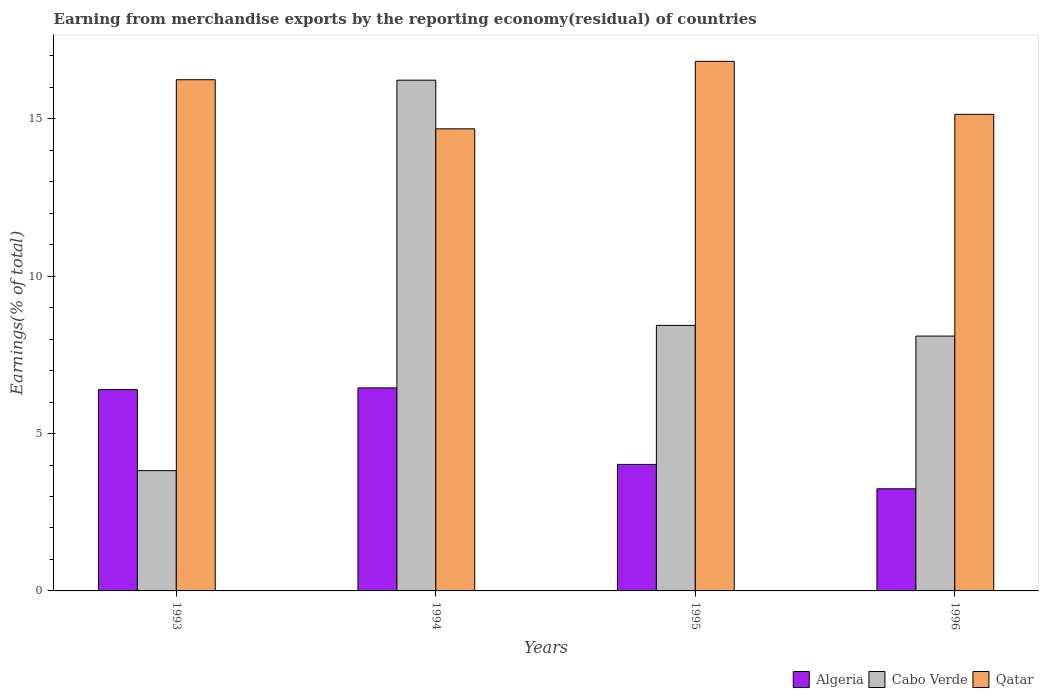How many different coloured bars are there?
Your response must be concise. 3. How many bars are there on the 3rd tick from the left?
Your response must be concise. 3. What is the label of the 4th group of bars from the left?
Provide a succinct answer. 1996. What is the percentage of amount earned from merchandise exports in Algeria in 1994?
Offer a terse response. 6.45. Across all years, what is the maximum percentage of amount earned from merchandise exports in Algeria?
Your answer should be very brief. 6.45. Across all years, what is the minimum percentage of amount earned from merchandise exports in Qatar?
Your answer should be compact. 14.68. What is the total percentage of amount earned from merchandise exports in Qatar in the graph?
Ensure brevity in your answer.  62.88. What is the difference between the percentage of amount earned from merchandise exports in Qatar in 1994 and that in 1996?
Give a very brief answer. -0.46. What is the difference between the percentage of amount earned from merchandise exports in Algeria in 1996 and the percentage of amount earned from merchandise exports in Qatar in 1994?
Your answer should be very brief. -11.44. What is the average percentage of amount earned from merchandise exports in Qatar per year?
Ensure brevity in your answer.  15.72. In the year 1995, what is the difference between the percentage of amount earned from merchandise exports in Qatar and percentage of amount earned from merchandise exports in Algeria?
Offer a very short reply. 12.8. In how many years, is the percentage of amount earned from merchandise exports in Cabo Verde greater than 8 %?
Provide a succinct answer. 3. What is the ratio of the percentage of amount earned from merchandise exports in Qatar in 1993 to that in 1996?
Provide a short and direct response. 1.07. What is the difference between the highest and the second highest percentage of amount earned from merchandise exports in Algeria?
Your answer should be compact. 0.05. What is the difference between the highest and the lowest percentage of amount earned from merchandise exports in Cabo Verde?
Your answer should be compact. 12.4. In how many years, is the percentage of amount earned from merchandise exports in Cabo Verde greater than the average percentage of amount earned from merchandise exports in Cabo Verde taken over all years?
Your answer should be compact. 1. Is the sum of the percentage of amount earned from merchandise exports in Cabo Verde in 1993 and 1995 greater than the maximum percentage of amount earned from merchandise exports in Algeria across all years?
Your response must be concise. Yes. What does the 1st bar from the left in 1996 represents?
Your answer should be very brief. Algeria. What does the 2nd bar from the right in 1993 represents?
Offer a terse response. Cabo Verde. Are all the bars in the graph horizontal?
Provide a succinct answer. No. Does the graph contain grids?
Provide a short and direct response. No. Where does the legend appear in the graph?
Keep it short and to the point. Bottom right. How many legend labels are there?
Give a very brief answer. 3. What is the title of the graph?
Your answer should be compact. Earning from merchandise exports by the reporting economy(residual) of countries. What is the label or title of the X-axis?
Your answer should be very brief. Years. What is the label or title of the Y-axis?
Provide a succinct answer. Earnings(% of total). What is the Earnings(% of total) in Algeria in 1993?
Your answer should be very brief. 6.4. What is the Earnings(% of total) in Cabo Verde in 1993?
Give a very brief answer. 3.82. What is the Earnings(% of total) of Qatar in 1993?
Offer a terse response. 16.24. What is the Earnings(% of total) in Algeria in 1994?
Keep it short and to the point. 6.45. What is the Earnings(% of total) in Cabo Verde in 1994?
Your response must be concise. 16.23. What is the Earnings(% of total) of Qatar in 1994?
Give a very brief answer. 14.68. What is the Earnings(% of total) in Algeria in 1995?
Make the answer very short. 4.02. What is the Earnings(% of total) in Cabo Verde in 1995?
Ensure brevity in your answer.  8.44. What is the Earnings(% of total) in Qatar in 1995?
Offer a terse response. 16.82. What is the Earnings(% of total) in Algeria in 1996?
Offer a terse response. 3.24. What is the Earnings(% of total) of Cabo Verde in 1996?
Give a very brief answer. 8.1. What is the Earnings(% of total) in Qatar in 1996?
Provide a succinct answer. 15.14. Across all years, what is the maximum Earnings(% of total) of Algeria?
Ensure brevity in your answer.  6.45. Across all years, what is the maximum Earnings(% of total) in Cabo Verde?
Ensure brevity in your answer.  16.23. Across all years, what is the maximum Earnings(% of total) of Qatar?
Offer a very short reply. 16.82. Across all years, what is the minimum Earnings(% of total) of Algeria?
Provide a short and direct response. 3.24. Across all years, what is the minimum Earnings(% of total) in Cabo Verde?
Your answer should be compact. 3.82. Across all years, what is the minimum Earnings(% of total) in Qatar?
Ensure brevity in your answer.  14.68. What is the total Earnings(% of total) of Algeria in the graph?
Your answer should be very brief. 20.11. What is the total Earnings(% of total) of Cabo Verde in the graph?
Keep it short and to the point. 36.58. What is the total Earnings(% of total) of Qatar in the graph?
Your answer should be compact. 62.88. What is the difference between the Earnings(% of total) in Algeria in 1993 and that in 1994?
Your response must be concise. -0.05. What is the difference between the Earnings(% of total) in Cabo Verde in 1993 and that in 1994?
Provide a short and direct response. -12.4. What is the difference between the Earnings(% of total) of Qatar in 1993 and that in 1994?
Give a very brief answer. 1.56. What is the difference between the Earnings(% of total) in Algeria in 1993 and that in 1995?
Make the answer very short. 2.38. What is the difference between the Earnings(% of total) of Cabo Verde in 1993 and that in 1995?
Keep it short and to the point. -4.61. What is the difference between the Earnings(% of total) in Qatar in 1993 and that in 1995?
Provide a succinct answer. -0.58. What is the difference between the Earnings(% of total) in Algeria in 1993 and that in 1996?
Your response must be concise. 3.15. What is the difference between the Earnings(% of total) of Cabo Verde in 1993 and that in 1996?
Provide a succinct answer. -4.27. What is the difference between the Earnings(% of total) in Qatar in 1993 and that in 1996?
Your answer should be compact. 1.1. What is the difference between the Earnings(% of total) of Algeria in 1994 and that in 1995?
Offer a very short reply. 2.43. What is the difference between the Earnings(% of total) of Cabo Verde in 1994 and that in 1995?
Keep it short and to the point. 7.79. What is the difference between the Earnings(% of total) of Qatar in 1994 and that in 1995?
Make the answer very short. -2.14. What is the difference between the Earnings(% of total) in Algeria in 1994 and that in 1996?
Provide a short and direct response. 3.21. What is the difference between the Earnings(% of total) of Cabo Verde in 1994 and that in 1996?
Provide a short and direct response. 8.13. What is the difference between the Earnings(% of total) in Qatar in 1994 and that in 1996?
Provide a short and direct response. -0.46. What is the difference between the Earnings(% of total) in Algeria in 1995 and that in 1996?
Offer a very short reply. 0.77. What is the difference between the Earnings(% of total) in Cabo Verde in 1995 and that in 1996?
Provide a succinct answer. 0.34. What is the difference between the Earnings(% of total) of Qatar in 1995 and that in 1996?
Your answer should be compact. 1.68. What is the difference between the Earnings(% of total) in Algeria in 1993 and the Earnings(% of total) in Cabo Verde in 1994?
Make the answer very short. -9.83. What is the difference between the Earnings(% of total) in Algeria in 1993 and the Earnings(% of total) in Qatar in 1994?
Your answer should be very brief. -8.28. What is the difference between the Earnings(% of total) in Cabo Verde in 1993 and the Earnings(% of total) in Qatar in 1994?
Your answer should be very brief. -10.86. What is the difference between the Earnings(% of total) in Algeria in 1993 and the Earnings(% of total) in Cabo Verde in 1995?
Provide a short and direct response. -2.04. What is the difference between the Earnings(% of total) in Algeria in 1993 and the Earnings(% of total) in Qatar in 1995?
Keep it short and to the point. -10.43. What is the difference between the Earnings(% of total) in Cabo Verde in 1993 and the Earnings(% of total) in Qatar in 1995?
Provide a succinct answer. -13. What is the difference between the Earnings(% of total) in Algeria in 1993 and the Earnings(% of total) in Cabo Verde in 1996?
Your answer should be very brief. -1.7. What is the difference between the Earnings(% of total) of Algeria in 1993 and the Earnings(% of total) of Qatar in 1996?
Make the answer very short. -8.74. What is the difference between the Earnings(% of total) in Cabo Verde in 1993 and the Earnings(% of total) in Qatar in 1996?
Provide a short and direct response. -11.32. What is the difference between the Earnings(% of total) of Algeria in 1994 and the Earnings(% of total) of Cabo Verde in 1995?
Offer a terse response. -1.99. What is the difference between the Earnings(% of total) in Algeria in 1994 and the Earnings(% of total) in Qatar in 1995?
Ensure brevity in your answer.  -10.37. What is the difference between the Earnings(% of total) in Cabo Verde in 1994 and the Earnings(% of total) in Qatar in 1995?
Offer a very short reply. -0.6. What is the difference between the Earnings(% of total) in Algeria in 1994 and the Earnings(% of total) in Cabo Verde in 1996?
Provide a short and direct response. -1.65. What is the difference between the Earnings(% of total) of Algeria in 1994 and the Earnings(% of total) of Qatar in 1996?
Provide a succinct answer. -8.69. What is the difference between the Earnings(% of total) of Cabo Verde in 1994 and the Earnings(% of total) of Qatar in 1996?
Offer a very short reply. 1.09. What is the difference between the Earnings(% of total) of Algeria in 1995 and the Earnings(% of total) of Cabo Verde in 1996?
Offer a very short reply. -4.08. What is the difference between the Earnings(% of total) of Algeria in 1995 and the Earnings(% of total) of Qatar in 1996?
Offer a terse response. -11.12. What is the difference between the Earnings(% of total) in Cabo Verde in 1995 and the Earnings(% of total) in Qatar in 1996?
Ensure brevity in your answer.  -6.7. What is the average Earnings(% of total) in Algeria per year?
Ensure brevity in your answer.  5.03. What is the average Earnings(% of total) of Cabo Verde per year?
Your answer should be compact. 9.14. What is the average Earnings(% of total) of Qatar per year?
Provide a short and direct response. 15.72. In the year 1993, what is the difference between the Earnings(% of total) in Algeria and Earnings(% of total) in Cabo Verde?
Give a very brief answer. 2.57. In the year 1993, what is the difference between the Earnings(% of total) of Algeria and Earnings(% of total) of Qatar?
Offer a very short reply. -9.85. In the year 1993, what is the difference between the Earnings(% of total) of Cabo Verde and Earnings(% of total) of Qatar?
Your answer should be compact. -12.42. In the year 1994, what is the difference between the Earnings(% of total) in Algeria and Earnings(% of total) in Cabo Verde?
Ensure brevity in your answer.  -9.78. In the year 1994, what is the difference between the Earnings(% of total) in Algeria and Earnings(% of total) in Qatar?
Your answer should be compact. -8.23. In the year 1994, what is the difference between the Earnings(% of total) of Cabo Verde and Earnings(% of total) of Qatar?
Give a very brief answer. 1.55. In the year 1995, what is the difference between the Earnings(% of total) in Algeria and Earnings(% of total) in Cabo Verde?
Your answer should be compact. -4.42. In the year 1995, what is the difference between the Earnings(% of total) of Algeria and Earnings(% of total) of Qatar?
Offer a very short reply. -12.8. In the year 1995, what is the difference between the Earnings(% of total) of Cabo Verde and Earnings(% of total) of Qatar?
Make the answer very short. -8.39. In the year 1996, what is the difference between the Earnings(% of total) of Algeria and Earnings(% of total) of Cabo Verde?
Your answer should be very brief. -4.85. In the year 1996, what is the difference between the Earnings(% of total) of Algeria and Earnings(% of total) of Qatar?
Your response must be concise. -11.9. In the year 1996, what is the difference between the Earnings(% of total) of Cabo Verde and Earnings(% of total) of Qatar?
Ensure brevity in your answer.  -7.04. What is the ratio of the Earnings(% of total) of Algeria in 1993 to that in 1994?
Ensure brevity in your answer.  0.99. What is the ratio of the Earnings(% of total) in Cabo Verde in 1993 to that in 1994?
Ensure brevity in your answer.  0.24. What is the ratio of the Earnings(% of total) in Qatar in 1993 to that in 1994?
Offer a terse response. 1.11. What is the ratio of the Earnings(% of total) in Algeria in 1993 to that in 1995?
Offer a very short reply. 1.59. What is the ratio of the Earnings(% of total) in Cabo Verde in 1993 to that in 1995?
Offer a very short reply. 0.45. What is the ratio of the Earnings(% of total) in Qatar in 1993 to that in 1995?
Ensure brevity in your answer.  0.97. What is the ratio of the Earnings(% of total) of Algeria in 1993 to that in 1996?
Provide a short and direct response. 1.97. What is the ratio of the Earnings(% of total) of Cabo Verde in 1993 to that in 1996?
Make the answer very short. 0.47. What is the ratio of the Earnings(% of total) in Qatar in 1993 to that in 1996?
Make the answer very short. 1.07. What is the ratio of the Earnings(% of total) of Algeria in 1994 to that in 1995?
Give a very brief answer. 1.6. What is the ratio of the Earnings(% of total) in Cabo Verde in 1994 to that in 1995?
Your answer should be compact. 1.92. What is the ratio of the Earnings(% of total) in Qatar in 1994 to that in 1995?
Make the answer very short. 0.87. What is the ratio of the Earnings(% of total) in Algeria in 1994 to that in 1996?
Ensure brevity in your answer.  1.99. What is the ratio of the Earnings(% of total) in Cabo Verde in 1994 to that in 1996?
Keep it short and to the point. 2. What is the ratio of the Earnings(% of total) of Qatar in 1994 to that in 1996?
Provide a succinct answer. 0.97. What is the ratio of the Earnings(% of total) in Algeria in 1995 to that in 1996?
Your answer should be very brief. 1.24. What is the ratio of the Earnings(% of total) in Cabo Verde in 1995 to that in 1996?
Keep it short and to the point. 1.04. What is the ratio of the Earnings(% of total) of Qatar in 1995 to that in 1996?
Keep it short and to the point. 1.11. What is the difference between the highest and the second highest Earnings(% of total) in Algeria?
Your answer should be very brief. 0.05. What is the difference between the highest and the second highest Earnings(% of total) of Cabo Verde?
Give a very brief answer. 7.79. What is the difference between the highest and the second highest Earnings(% of total) in Qatar?
Keep it short and to the point. 0.58. What is the difference between the highest and the lowest Earnings(% of total) in Algeria?
Give a very brief answer. 3.21. What is the difference between the highest and the lowest Earnings(% of total) of Cabo Verde?
Your answer should be very brief. 12.4. What is the difference between the highest and the lowest Earnings(% of total) of Qatar?
Your answer should be very brief. 2.14. 